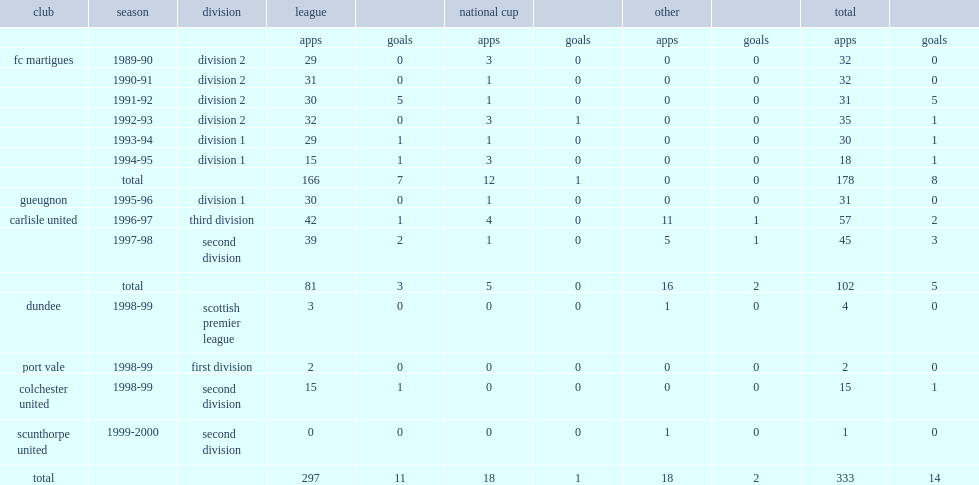Which club did pounewatchy play for in 1997-98? Carlisle united. 